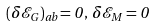<formula> <loc_0><loc_0><loc_500><loc_500>( \delta \mathcal { E } _ { G } ) _ { a b } = 0 \, , \, \delta \mathcal { E } _ { M } = 0</formula> 